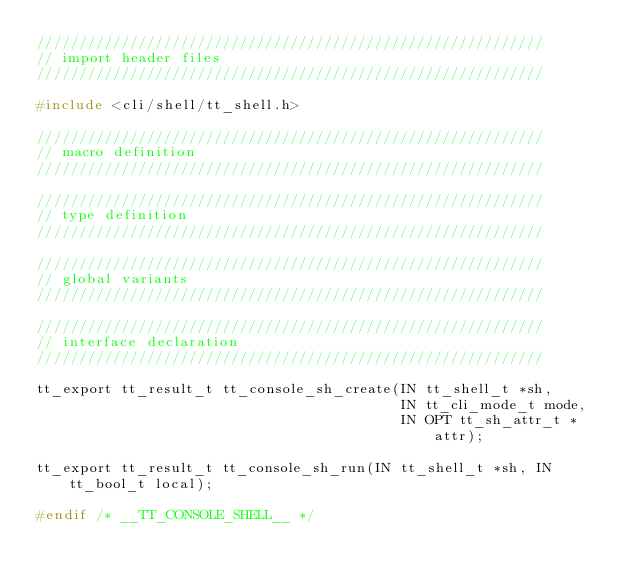<code> <loc_0><loc_0><loc_500><loc_500><_C_>////////////////////////////////////////////////////////////
// import header files
////////////////////////////////////////////////////////////

#include <cli/shell/tt_shell.h>

////////////////////////////////////////////////////////////
// macro definition
////////////////////////////////////////////////////////////

////////////////////////////////////////////////////////////
// type definition
////////////////////////////////////////////////////////////

////////////////////////////////////////////////////////////
// global variants
////////////////////////////////////////////////////////////

////////////////////////////////////////////////////////////
// interface declaration
////////////////////////////////////////////////////////////

tt_export tt_result_t tt_console_sh_create(IN tt_shell_t *sh,
                                           IN tt_cli_mode_t mode,
                                           IN OPT tt_sh_attr_t *attr);

tt_export tt_result_t tt_console_sh_run(IN tt_shell_t *sh, IN tt_bool_t local);

#endif /* __TT_CONSOLE_SHELL__ */
</code> 